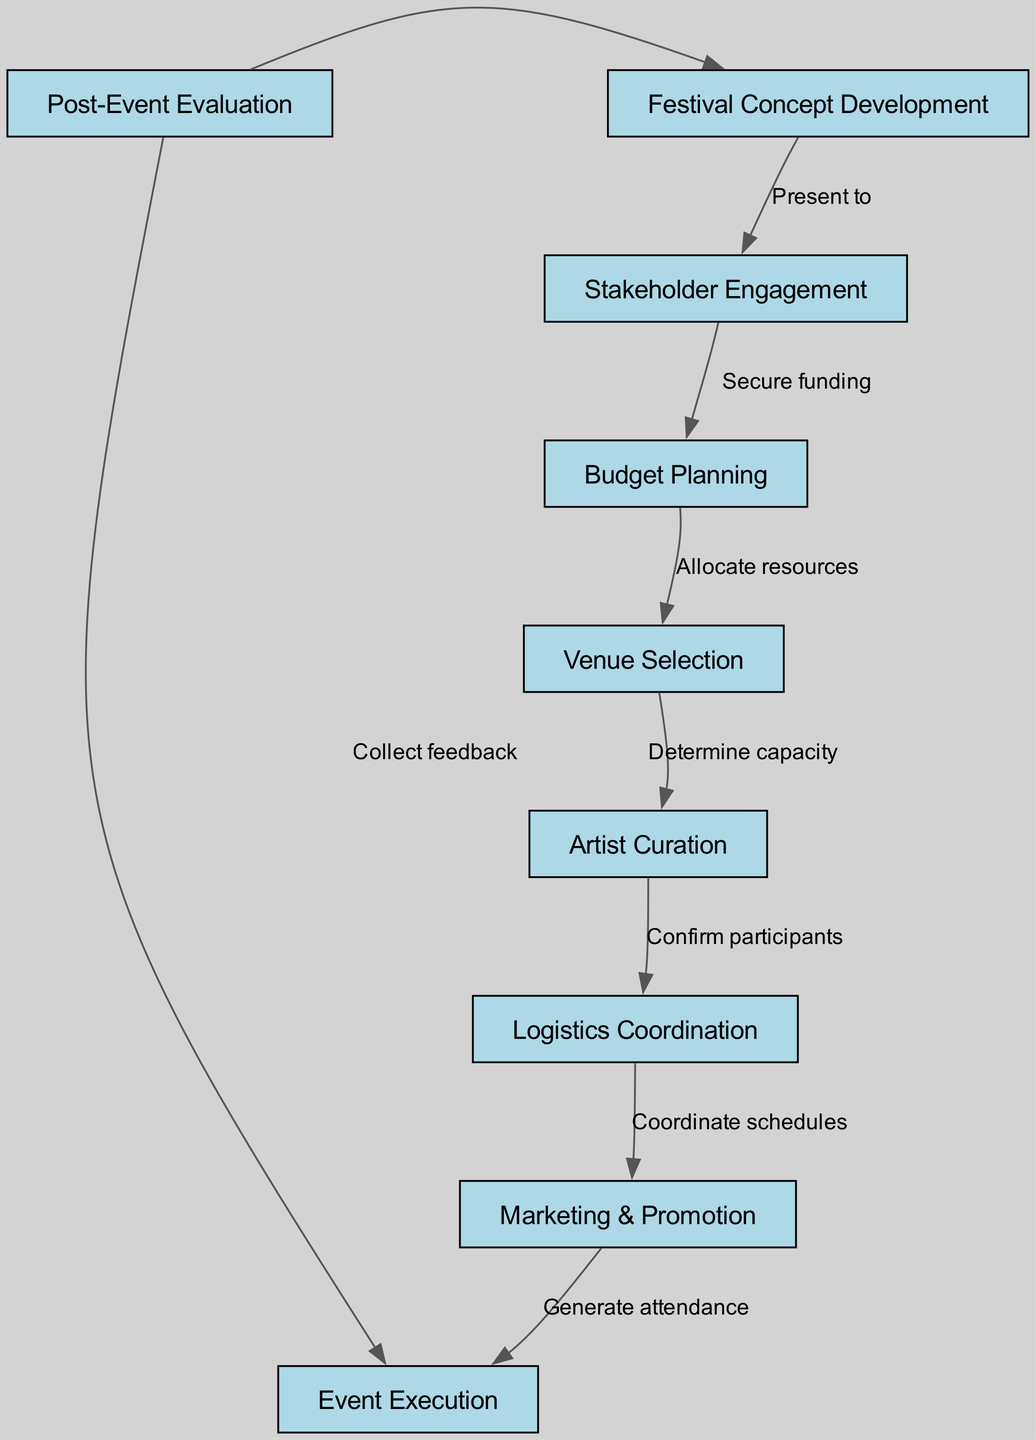What is the total number of nodes in this diagram? There are 9 nodes listed in the diagram, each representing a distinct stage in the community arts festival planning process.
Answer: 9 What does the edge from "Festival Concept Development" to "Stakeholder Engagement" represent? The edge indicates a relationship where the festival concept is presented to stakeholders, showcasing the flow of the planning process.
Answer: Present to Which node follows "Artist Curation" in the process flow? "Logistics Coordination" comes immediately after "Artist Curation," indicating the next step in planning.
Answer: Logistics Coordination What is the final step of the community arts festival planning process? The last node in the flow is "Post-Event Evaluation," which focuses on assessing the festival after it has taken place.
Answer: Post-Event Evaluation How many edges are present in the diagram? There are a total of 8 edges connecting the nodes, illustrating the relationships and sequence of activities in the planning process.
Answer: 8 What action is taken after "Event Execution"? After "Event Execution," the next step is to "Collect feedback," highlighting the importance of evaluation following the event.
Answer: Collect feedback In the node "Budget Planning," what is the primary action being undertaken? The primary action in "Budget Planning" is to allocate resources, essential for financial management during the planning process.
Answer: Allocate resources How is feedback utilized in the community arts festival planning process? Feedback collected in "Post-Event Evaluation" is used to improve the next iteration of the festival, demonstrating a cyclic approach to planning.
Answer: Improve next iteration What is the relationship between "Marketing & Promotion" and "Event Execution"? The relationship indicates that marketing efforts aim to generate attendance, which is crucial for the actual execution of the event.
Answer: Generate attendance 